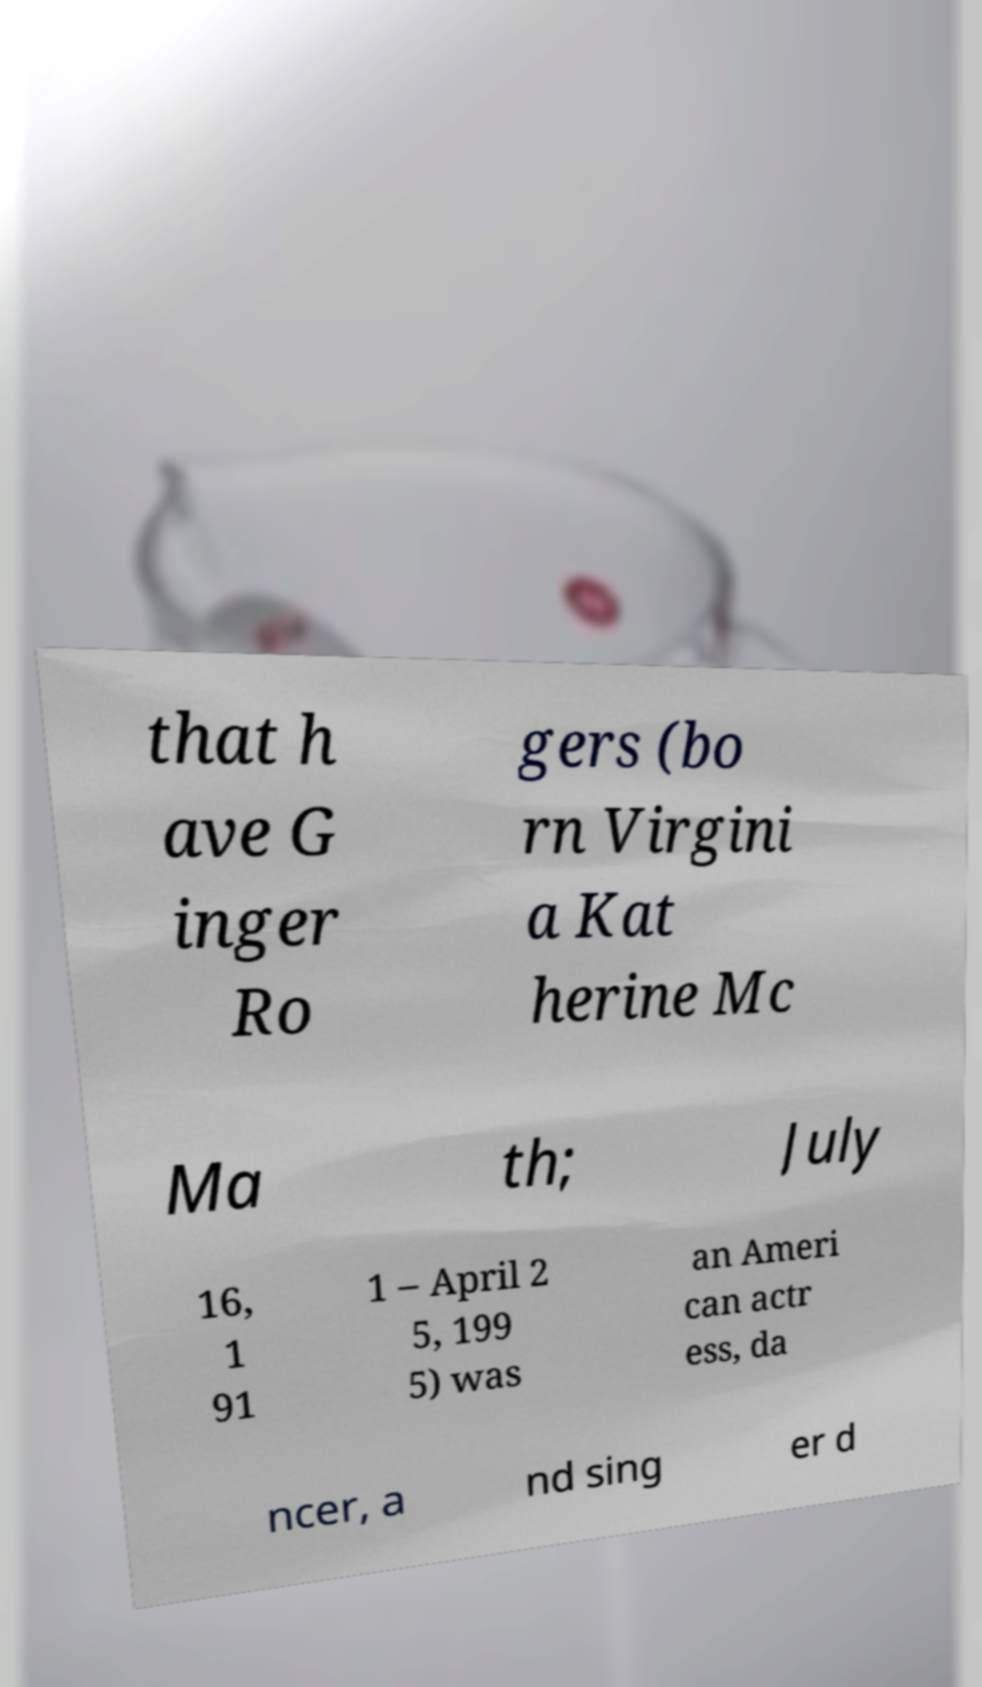Could you assist in decoding the text presented in this image and type it out clearly? that h ave G inger Ro gers (bo rn Virgini a Kat herine Mc Ma th; July 16, 1 91 1 – April 2 5, 199 5) was an Ameri can actr ess, da ncer, a nd sing er d 